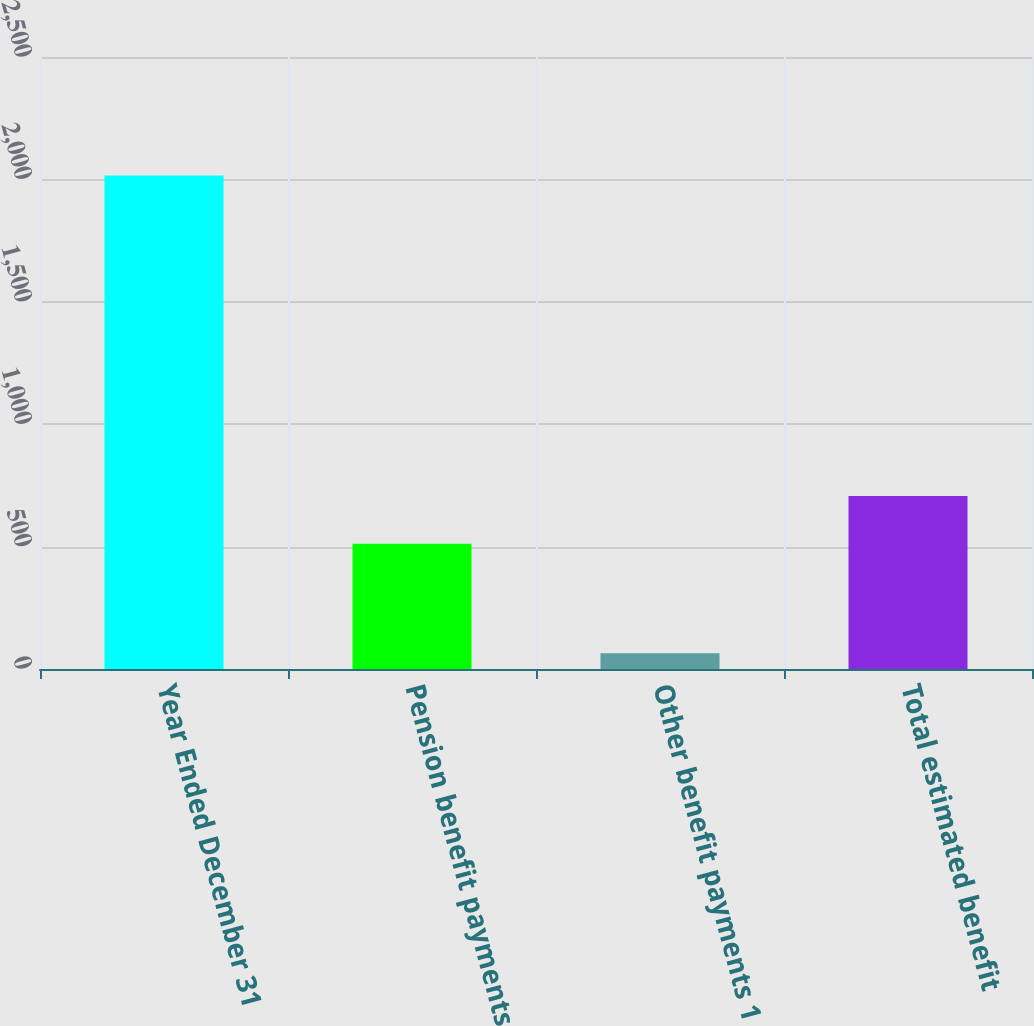Convert chart to OTSL. <chart><loc_0><loc_0><loc_500><loc_500><bar_chart><fcel>Year Ended December 31<fcel>Pension benefit payments<fcel>Other benefit payments 1<fcel>Total estimated benefit<nl><fcel>2016<fcel>512<fcel>64<fcel>707.2<nl></chart> 